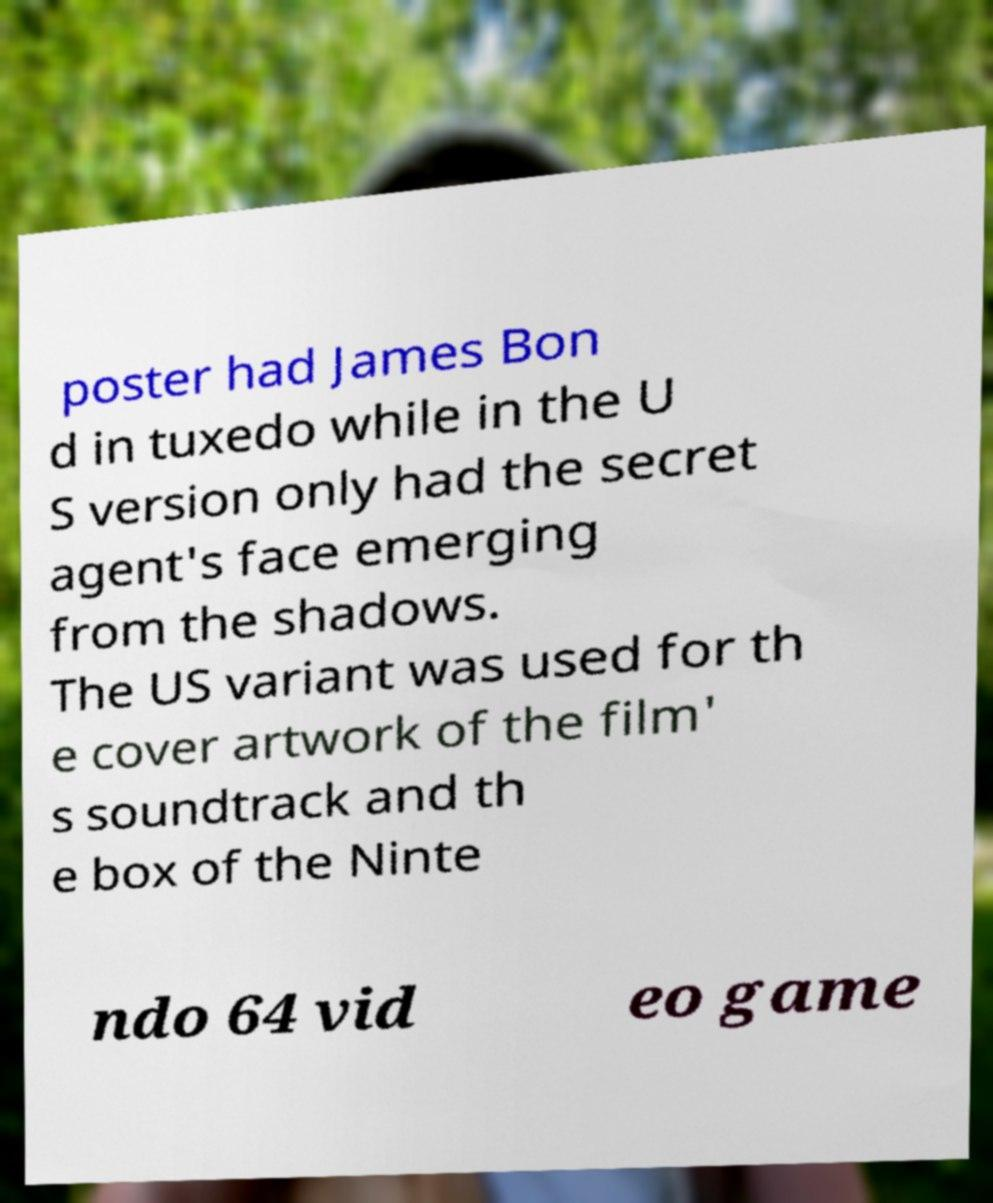Could you extract and type out the text from this image? poster had James Bon d in tuxedo while in the U S version only had the secret agent's face emerging from the shadows. The US variant was used for th e cover artwork of the film' s soundtrack and th e box of the Ninte ndo 64 vid eo game 